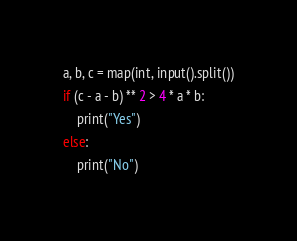<code> <loc_0><loc_0><loc_500><loc_500><_Python_>a, b, c = map(int, input().split())
if (c - a - b) ** 2 > 4 * a * b:
    print("Yes")
else:
    print("No")</code> 